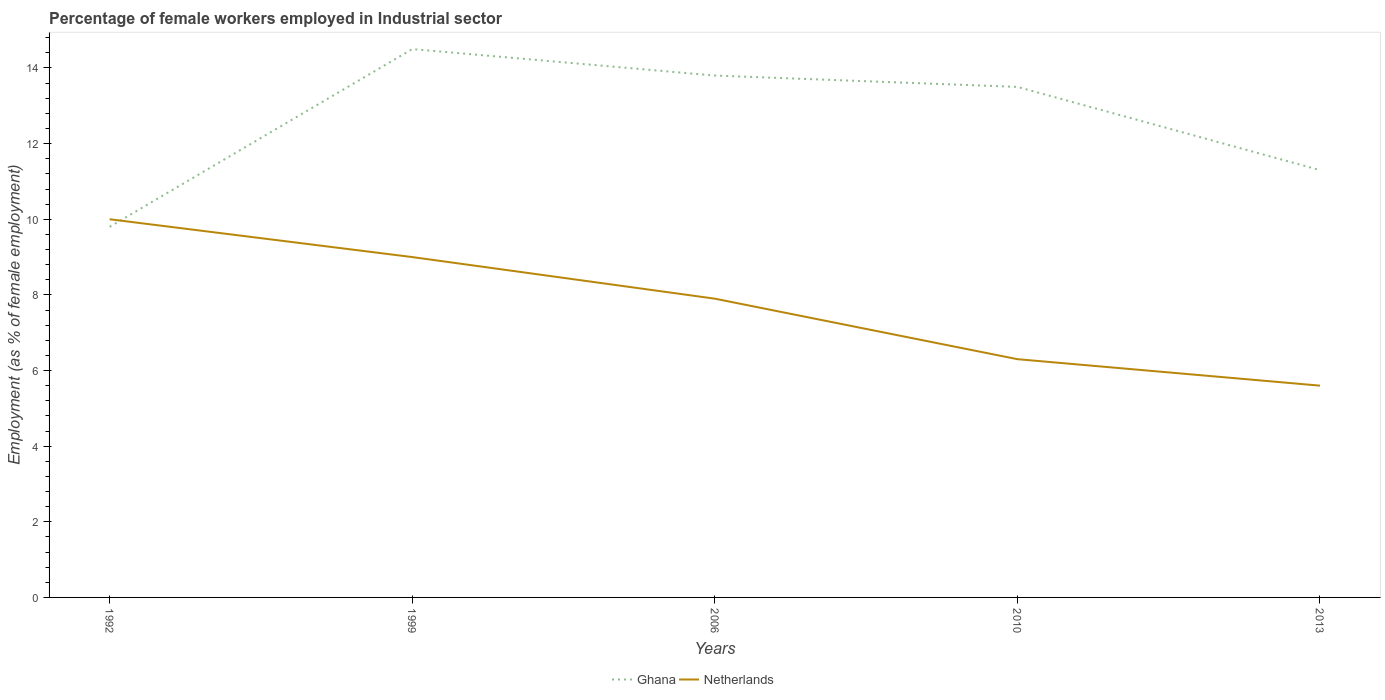How many different coloured lines are there?
Provide a short and direct response. 2. Does the line corresponding to Netherlands intersect with the line corresponding to Ghana?
Your response must be concise. Yes. Across all years, what is the maximum percentage of females employed in Industrial sector in Netherlands?
Keep it short and to the point. 5.6. In which year was the percentage of females employed in Industrial sector in Ghana maximum?
Your answer should be very brief. 1992. What is the total percentage of females employed in Industrial sector in Netherlands in the graph?
Provide a succinct answer. 2.3. What is the difference between the highest and the second highest percentage of females employed in Industrial sector in Netherlands?
Provide a short and direct response. 4.4. How many lines are there?
Offer a very short reply. 2. How many legend labels are there?
Your answer should be very brief. 2. How are the legend labels stacked?
Your answer should be very brief. Horizontal. What is the title of the graph?
Offer a very short reply. Percentage of female workers employed in Industrial sector. What is the label or title of the Y-axis?
Keep it short and to the point. Employment (as % of female employment). What is the Employment (as % of female employment) of Ghana in 1992?
Ensure brevity in your answer.  9.8. What is the Employment (as % of female employment) of Ghana in 1999?
Make the answer very short. 14.5. What is the Employment (as % of female employment) in Netherlands in 1999?
Make the answer very short. 9. What is the Employment (as % of female employment) in Ghana in 2006?
Ensure brevity in your answer.  13.8. What is the Employment (as % of female employment) in Netherlands in 2006?
Make the answer very short. 7.9. What is the Employment (as % of female employment) of Netherlands in 2010?
Offer a terse response. 6.3. What is the Employment (as % of female employment) in Ghana in 2013?
Ensure brevity in your answer.  11.3. What is the Employment (as % of female employment) of Netherlands in 2013?
Give a very brief answer. 5.6. Across all years, what is the maximum Employment (as % of female employment) of Ghana?
Give a very brief answer. 14.5. Across all years, what is the maximum Employment (as % of female employment) in Netherlands?
Your answer should be very brief. 10. Across all years, what is the minimum Employment (as % of female employment) in Ghana?
Provide a short and direct response. 9.8. Across all years, what is the minimum Employment (as % of female employment) of Netherlands?
Your answer should be compact. 5.6. What is the total Employment (as % of female employment) in Ghana in the graph?
Your answer should be very brief. 62.9. What is the total Employment (as % of female employment) in Netherlands in the graph?
Your answer should be compact. 38.8. What is the difference between the Employment (as % of female employment) in Ghana in 1992 and that in 2010?
Your answer should be compact. -3.7. What is the difference between the Employment (as % of female employment) in Ghana in 1992 and that in 2013?
Offer a very short reply. -1.5. What is the difference between the Employment (as % of female employment) in Ghana in 1999 and that in 2006?
Your response must be concise. 0.7. What is the difference between the Employment (as % of female employment) in Netherlands in 1999 and that in 2006?
Offer a terse response. 1.1. What is the difference between the Employment (as % of female employment) of Ghana in 1999 and that in 2010?
Provide a succinct answer. 1. What is the difference between the Employment (as % of female employment) of Netherlands in 1999 and that in 2010?
Your response must be concise. 2.7. What is the difference between the Employment (as % of female employment) of Ghana in 1999 and that in 2013?
Give a very brief answer. 3.2. What is the difference between the Employment (as % of female employment) of Ghana in 2006 and that in 2010?
Ensure brevity in your answer.  0.3. What is the difference between the Employment (as % of female employment) in Ghana in 2006 and that in 2013?
Provide a succinct answer. 2.5. What is the difference between the Employment (as % of female employment) of Netherlands in 2006 and that in 2013?
Ensure brevity in your answer.  2.3. What is the difference between the Employment (as % of female employment) of Ghana in 2010 and that in 2013?
Provide a short and direct response. 2.2. What is the difference between the Employment (as % of female employment) in Ghana in 1992 and the Employment (as % of female employment) in Netherlands in 1999?
Make the answer very short. 0.8. What is the difference between the Employment (as % of female employment) of Ghana in 1992 and the Employment (as % of female employment) of Netherlands in 2006?
Offer a very short reply. 1.9. What is the difference between the Employment (as % of female employment) of Ghana in 1999 and the Employment (as % of female employment) of Netherlands in 2010?
Give a very brief answer. 8.2. What is the difference between the Employment (as % of female employment) in Ghana in 2006 and the Employment (as % of female employment) in Netherlands in 2010?
Provide a short and direct response. 7.5. What is the difference between the Employment (as % of female employment) of Ghana in 2010 and the Employment (as % of female employment) of Netherlands in 2013?
Ensure brevity in your answer.  7.9. What is the average Employment (as % of female employment) in Ghana per year?
Your response must be concise. 12.58. What is the average Employment (as % of female employment) in Netherlands per year?
Provide a succinct answer. 7.76. In the year 1999, what is the difference between the Employment (as % of female employment) of Ghana and Employment (as % of female employment) of Netherlands?
Make the answer very short. 5.5. In the year 2010, what is the difference between the Employment (as % of female employment) in Ghana and Employment (as % of female employment) in Netherlands?
Offer a very short reply. 7.2. In the year 2013, what is the difference between the Employment (as % of female employment) in Ghana and Employment (as % of female employment) in Netherlands?
Offer a very short reply. 5.7. What is the ratio of the Employment (as % of female employment) of Ghana in 1992 to that in 1999?
Offer a terse response. 0.68. What is the ratio of the Employment (as % of female employment) in Netherlands in 1992 to that in 1999?
Give a very brief answer. 1.11. What is the ratio of the Employment (as % of female employment) of Ghana in 1992 to that in 2006?
Ensure brevity in your answer.  0.71. What is the ratio of the Employment (as % of female employment) in Netherlands in 1992 to that in 2006?
Your response must be concise. 1.27. What is the ratio of the Employment (as % of female employment) in Ghana in 1992 to that in 2010?
Ensure brevity in your answer.  0.73. What is the ratio of the Employment (as % of female employment) in Netherlands in 1992 to that in 2010?
Your response must be concise. 1.59. What is the ratio of the Employment (as % of female employment) of Ghana in 1992 to that in 2013?
Offer a terse response. 0.87. What is the ratio of the Employment (as % of female employment) of Netherlands in 1992 to that in 2013?
Your answer should be compact. 1.79. What is the ratio of the Employment (as % of female employment) of Ghana in 1999 to that in 2006?
Your answer should be very brief. 1.05. What is the ratio of the Employment (as % of female employment) in Netherlands in 1999 to that in 2006?
Make the answer very short. 1.14. What is the ratio of the Employment (as % of female employment) in Ghana in 1999 to that in 2010?
Give a very brief answer. 1.07. What is the ratio of the Employment (as % of female employment) in Netherlands in 1999 to that in 2010?
Your answer should be compact. 1.43. What is the ratio of the Employment (as % of female employment) in Ghana in 1999 to that in 2013?
Your answer should be very brief. 1.28. What is the ratio of the Employment (as % of female employment) of Netherlands in 1999 to that in 2013?
Provide a succinct answer. 1.61. What is the ratio of the Employment (as % of female employment) of Ghana in 2006 to that in 2010?
Provide a succinct answer. 1.02. What is the ratio of the Employment (as % of female employment) of Netherlands in 2006 to that in 2010?
Provide a short and direct response. 1.25. What is the ratio of the Employment (as % of female employment) in Ghana in 2006 to that in 2013?
Keep it short and to the point. 1.22. What is the ratio of the Employment (as % of female employment) in Netherlands in 2006 to that in 2013?
Your response must be concise. 1.41. What is the ratio of the Employment (as % of female employment) in Ghana in 2010 to that in 2013?
Your answer should be compact. 1.19. What is the ratio of the Employment (as % of female employment) of Netherlands in 2010 to that in 2013?
Offer a terse response. 1.12. What is the difference between the highest and the second highest Employment (as % of female employment) of Ghana?
Provide a short and direct response. 0.7. What is the difference between the highest and the second highest Employment (as % of female employment) of Netherlands?
Offer a terse response. 1. 